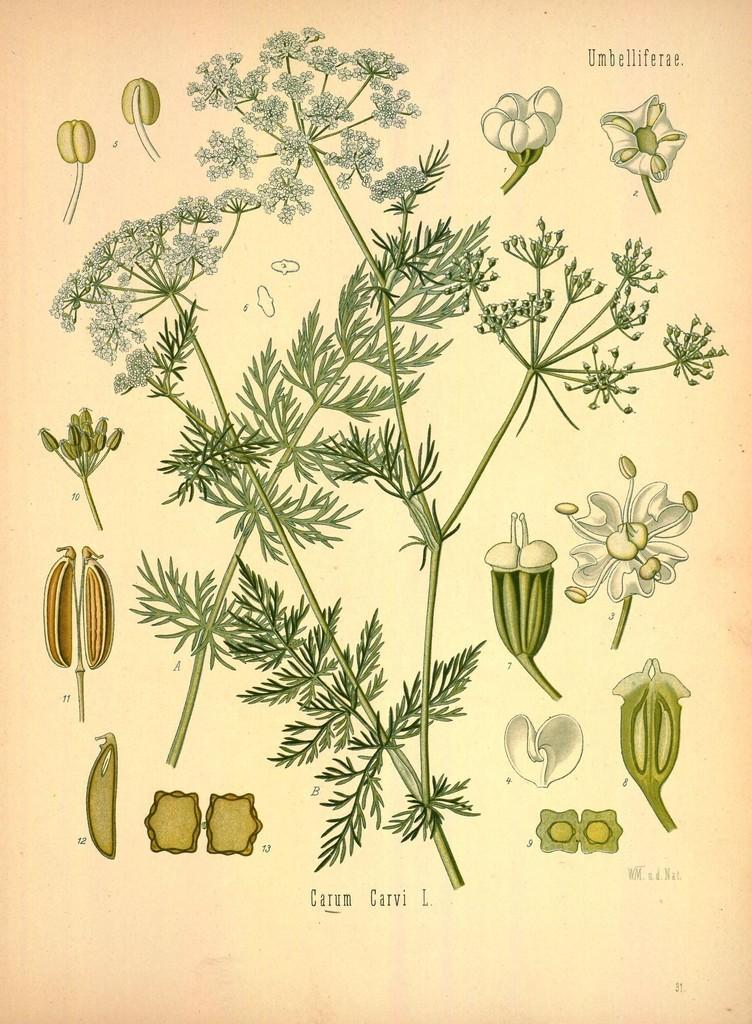Could you give a brief overview of what you see in this image? In this image we can see poster of a plant which has some leaves, flowers and some other items. 